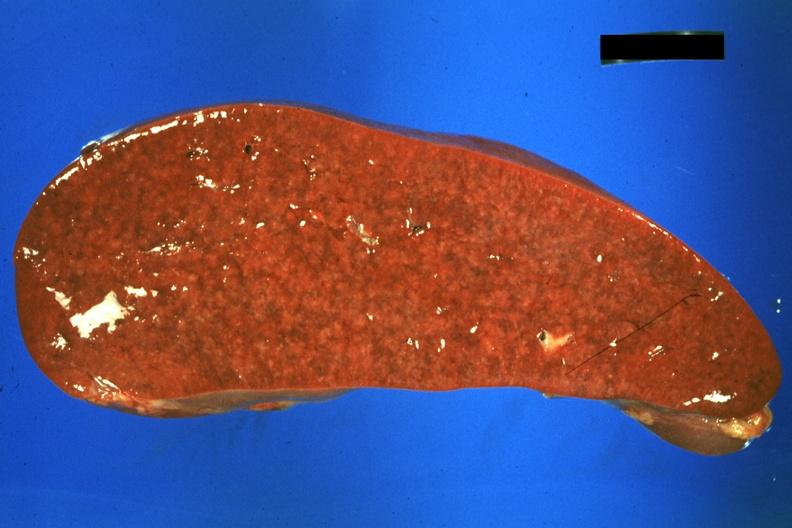what is present?
Answer the question using a single word or phrase. Sarcoidosis 